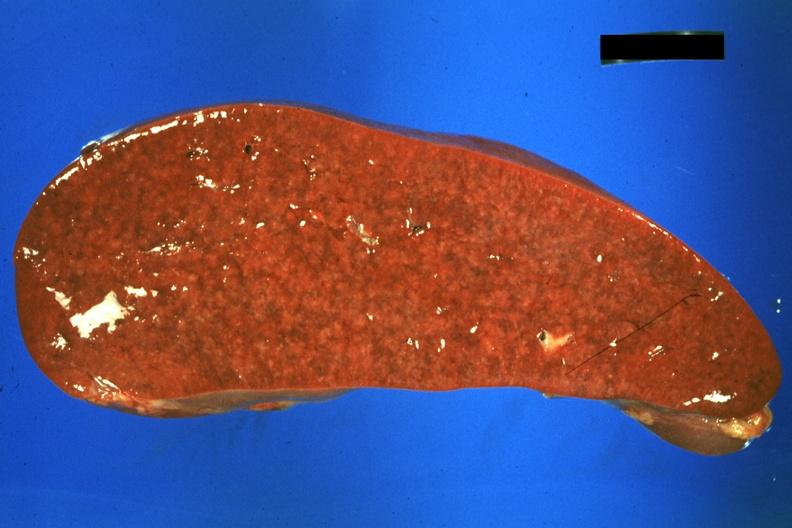what is present?
Answer the question using a single word or phrase. Sarcoidosis 